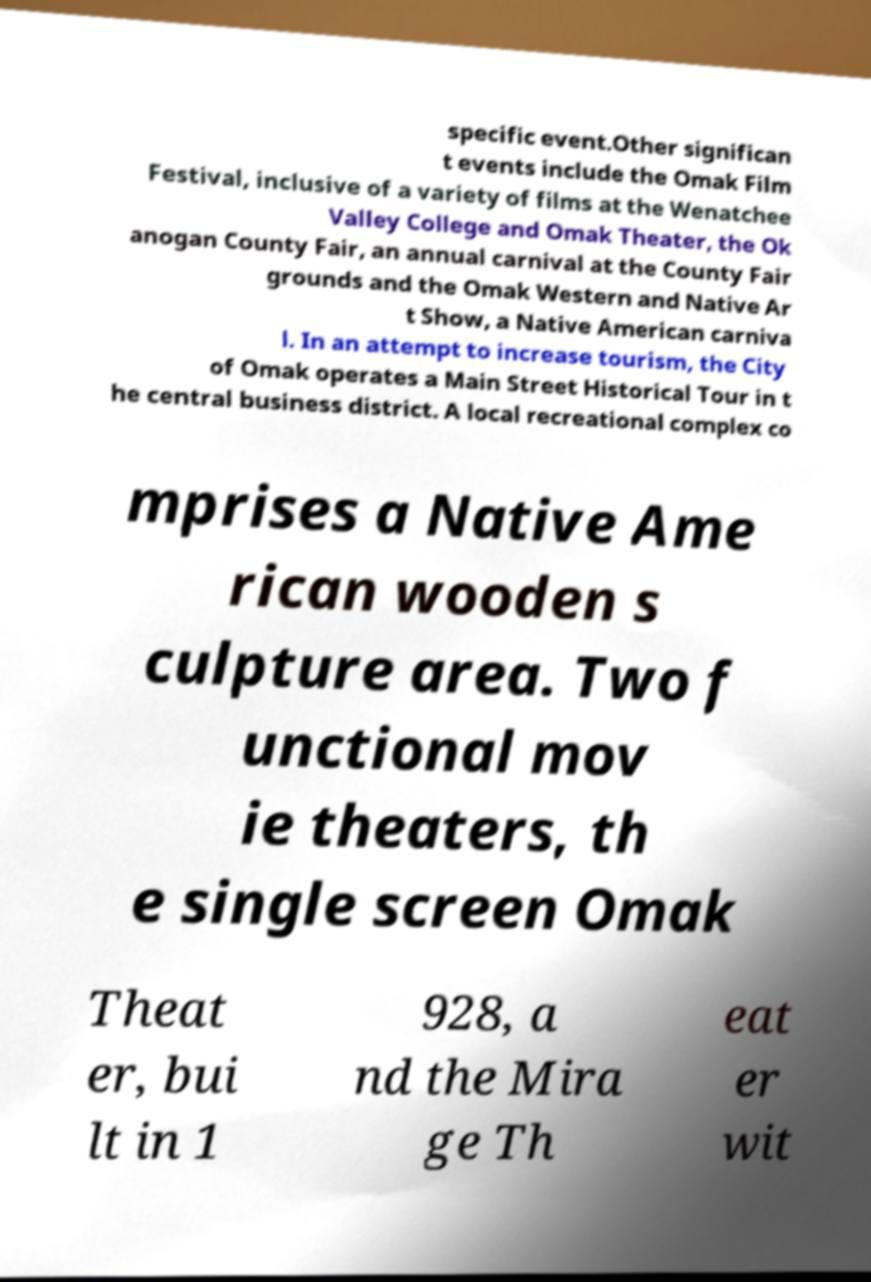Could you assist in decoding the text presented in this image and type it out clearly? specific event.Other significan t events include the Omak Film Festival, inclusive of a variety of films at the Wenatchee Valley College and Omak Theater, the Ok anogan County Fair, an annual carnival at the County Fair grounds and the Omak Western and Native Ar t Show, a Native American carniva l. In an attempt to increase tourism, the City of Omak operates a Main Street Historical Tour in t he central business district. A local recreational complex co mprises a Native Ame rican wooden s culpture area. Two f unctional mov ie theaters, th e single screen Omak Theat er, bui lt in 1 928, a nd the Mira ge Th eat er wit 